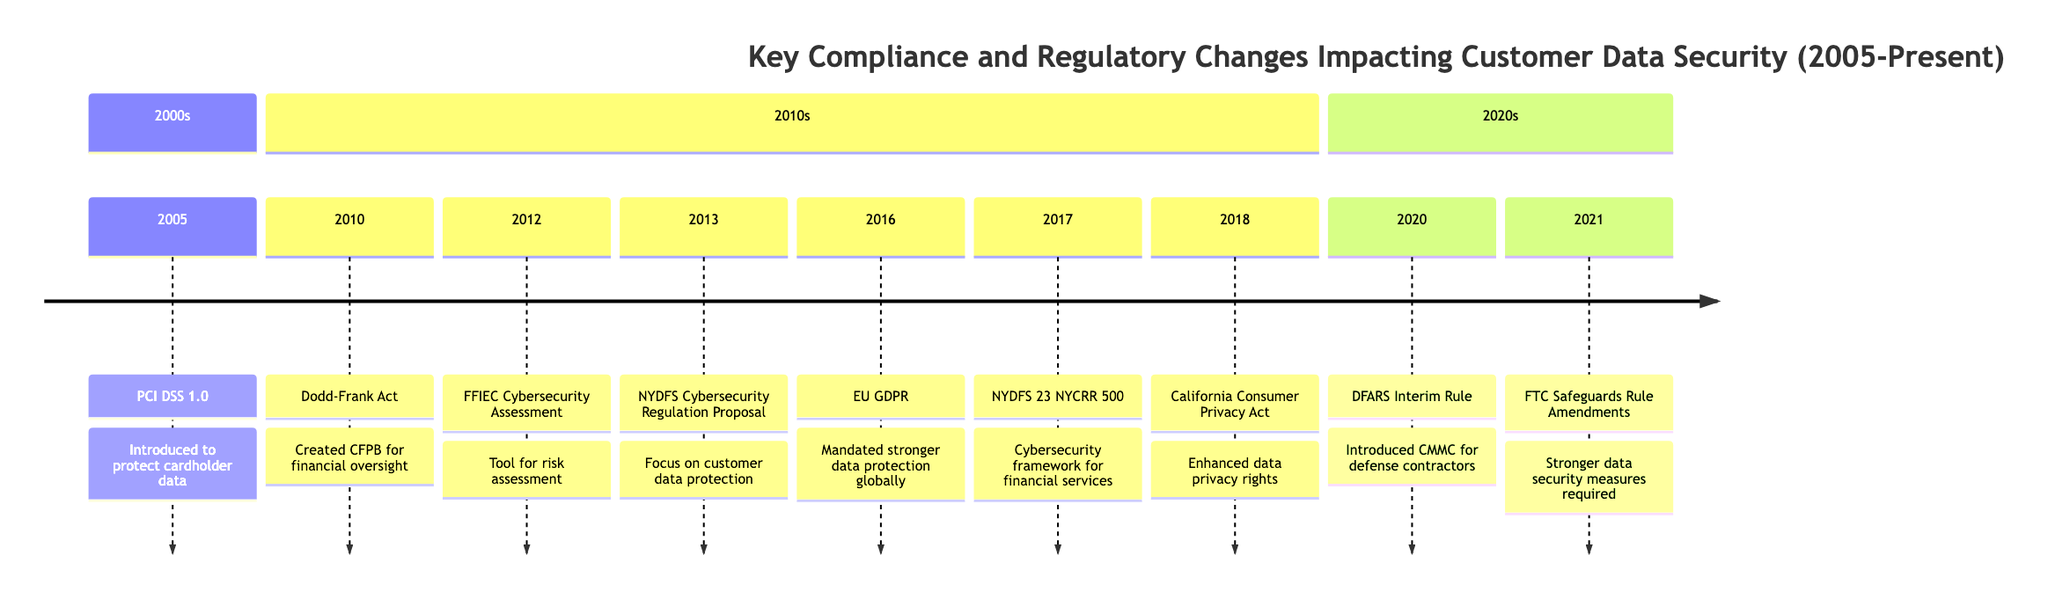What regulation was introduced in 2005? The diagram shows that the regulation introduced in 2005 is PCI DSS 1.0. This is indicated by the timeline position and the description associated with that year.
Answer: PCI DSS 1.0 How many major regulatory changes occurred in the 2010s? By counting the entries listed under the 2010s section of the timeline, there were 6 major regulatory changes from 2010 to 2018.
Answer: 6 What does GDPR stand for? The acronym GDPR, as presented in the 2016 entry of the timeline, stands for General Data Protection Regulation.
Answer: General Data Protection Regulation Which regulation focused on customer data protection in 2013? The timeline entry for 2013 indicates that the NYDFS Cybersecurity Regulation Proposal was the regulation focused on customer data protection.
Answer: NYDFS Cybersecurity Regulation Proposal What regulatory change was implemented in 2021? The diagram indicates that the FTC Safeguards Rule Amendments were the regulatory change implemented in 2021 under the Gramm-Leach-Bliley Act.
Answer: FTC Safeguards Rule Amendments Which year saw the introduction of the CCPA? According to the timeline, the California Consumer Privacy Act (CCPA) was signed into law in 2018, as noted in that specific year's entry.
Answer: 2018 What is the primary focus of NYDFS 23 NYCRR 500? The description under the 2017 entry explains that NYDFS 23 NYCRR 500 focuses on a robust cybersecurity framework and the protection of nonpublic information.
Answer: Cybersecurity framework How does the Dodd-Frank Act impact customer data security? The Dodd-Frank Act, introduced in 2010, created the CFPB which oversees financial institutions, thereby indirectly affecting customer data security by enhancing regulatory oversight.
Answer: Created CFPB for financial oversight What regulatory change was introduced for defense contractors in 2020? The timeline shows that in 2020, the DFARS Interim Rule introduced the Cybersecurity Maturity Model Certification (CMMC) as a new standard for defense contractors.
Answer: DFARS Interim Rule 